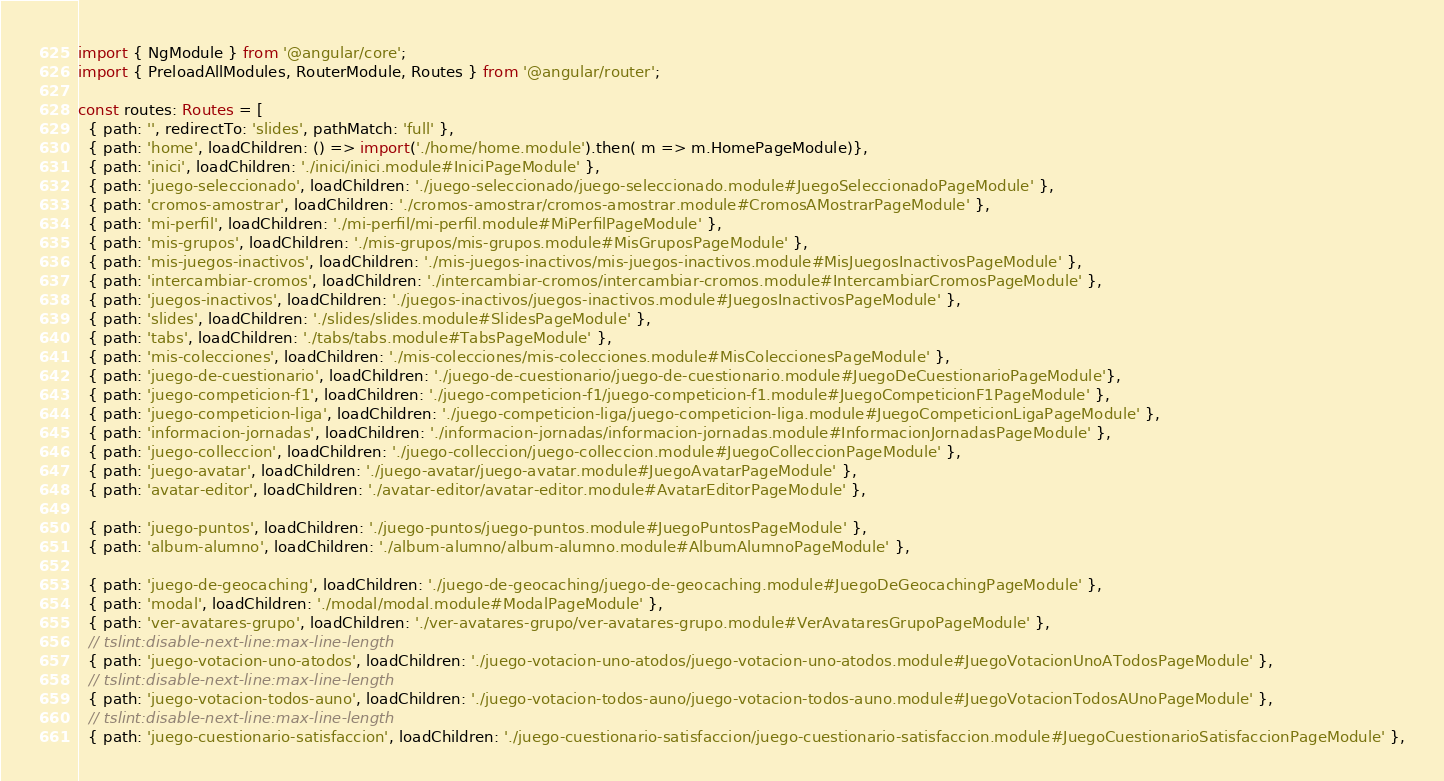Convert code to text. <code><loc_0><loc_0><loc_500><loc_500><_TypeScript_>
import { NgModule } from '@angular/core';
import { PreloadAllModules, RouterModule, Routes } from '@angular/router';

const routes: Routes = [
  { path: '', redirectTo: 'slides', pathMatch: 'full' },
  { path: 'home', loadChildren: () => import('./home/home.module').then( m => m.HomePageModule)},
  { path: 'inici', loadChildren: './inici/inici.module#IniciPageModule' },
  { path: 'juego-seleccionado', loadChildren: './juego-seleccionado/juego-seleccionado.module#JuegoSeleccionadoPageModule' },
  { path: 'cromos-amostrar', loadChildren: './cromos-amostrar/cromos-amostrar.module#CromosAMostrarPageModule' },
  { path: 'mi-perfil', loadChildren: './mi-perfil/mi-perfil.module#MiPerfilPageModule' },
  { path: 'mis-grupos', loadChildren: './mis-grupos/mis-grupos.module#MisGruposPageModule' },
  { path: 'mis-juegos-inactivos', loadChildren: './mis-juegos-inactivos/mis-juegos-inactivos.module#MisJuegosInactivosPageModule' },
  { path: 'intercambiar-cromos', loadChildren: './intercambiar-cromos/intercambiar-cromos.module#IntercambiarCromosPageModule' },
  { path: 'juegos-inactivos', loadChildren: './juegos-inactivos/juegos-inactivos.module#JuegosInactivosPageModule' },
  { path: 'slides', loadChildren: './slides/slides.module#SlidesPageModule' },
  { path: 'tabs', loadChildren: './tabs/tabs.module#TabsPageModule' },
  { path: 'mis-colecciones', loadChildren: './mis-colecciones/mis-colecciones.module#MisColeccionesPageModule' },
  { path: 'juego-de-cuestionario', loadChildren: './juego-de-cuestionario/juego-de-cuestionario.module#JuegoDeCuestionarioPageModule'},
  { path: 'juego-competicion-f1', loadChildren: './juego-competicion-f1/juego-competicion-f1.module#JuegoCompeticionF1PageModule' },
  { path: 'juego-competicion-liga', loadChildren: './juego-competicion-liga/juego-competicion-liga.module#JuegoCompeticionLigaPageModule' },
  { path: 'informacion-jornadas', loadChildren: './informacion-jornadas/informacion-jornadas.module#InformacionJornadasPageModule' },
  { path: 'juego-colleccion', loadChildren: './juego-colleccion/juego-colleccion.module#JuegoColleccionPageModule' },
  { path: 'juego-avatar', loadChildren: './juego-avatar/juego-avatar.module#JuegoAvatarPageModule' },
  { path: 'avatar-editor', loadChildren: './avatar-editor/avatar-editor.module#AvatarEditorPageModule' },
  
  { path: 'juego-puntos', loadChildren: './juego-puntos/juego-puntos.module#JuegoPuntosPageModule' },
  { path: 'album-alumno', loadChildren: './album-alumno/album-alumno.module#AlbumAlumnoPageModule' },

  { path: 'juego-de-geocaching', loadChildren: './juego-de-geocaching/juego-de-geocaching.module#JuegoDeGeocachingPageModule' },
  { path: 'modal', loadChildren: './modal/modal.module#ModalPageModule' },
  { path: 'ver-avatares-grupo', loadChildren: './ver-avatares-grupo/ver-avatares-grupo.module#VerAvataresGrupoPageModule' },
  // tslint:disable-next-line:max-line-length
  { path: 'juego-votacion-uno-atodos', loadChildren: './juego-votacion-uno-atodos/juego-votacion-uno-atodos.module#JuegoVotacionUnoATodosPageModule' },
  // tslint:disable-next-line:max-line-length
  { path: 'juego-votacion-todos-auno', loadChildren: './juego-votacion-todos-auno/juego-votacion-todos-auno.module#JuegoVotacionTodosAUnoPageModule' },
  // tslint:disable-next-line:max-line-length
  { path: 'juego-cuestionario-satisfaccion', loadChildren: './juego-cuestionario-satisfaccion/juego-cuestionario-satisfaccion.module#JuegoCuestionarioSatisfaccionPageModule' },</code> 